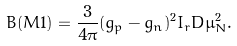<formula> <loc_0><loc_0><loc_500><loc_500>B ( M 1 ) = \frac { 3 } { 4 \pi } ( g _ { p } - g _ { n } ) ^ { 2 } I _ { r } D \mu _ { N } ^ { 2 } .</formula> 